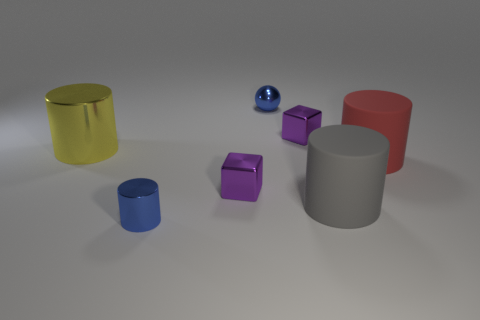Subtract all yellow cylinders. How many cylinders are left? 3 Subtract all yellow cylinders. How many cylinders are left? 3 Subtract all gray cylinders. Subtract all gray spheres. How many cylinders are left? 3 Add 1 small green cylinders. How many objects exist? 8 Subtract all cubes. How many objects are left? 5 Subtract all blue objects. Subtract all big yellow shiny objects. How many objects are left? 4 Add 3 tiny purple objects. How many tiny purple objects are left? 5 Add 7 big brown metallic balls. How many big brown metallic balls exist? 7 Subtract 1 red cylinders. How many objects are left? 6 